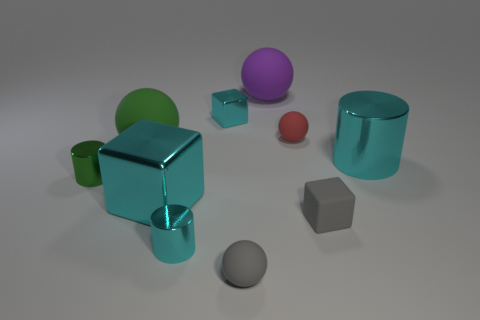Subtract 1 spheres. How many spheres are left? 3 Subtract all cylinders. How many objects are left? 7 Add 4 small red metallic cylinders. How many small red metallic cylinders exist? 4 Subtract 0 purple cylinders. How many objects are left? 10 Subtract all big purple balls. Subtract all small rubber cubes. How many objects are left? 8 Add 4 big cyan blocks. How many big cyan blocks are left? 5 